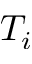Convert formula to latex. <formula><loc_0><loc_0><loc_500><loc_500>T _ { i }</formula> 